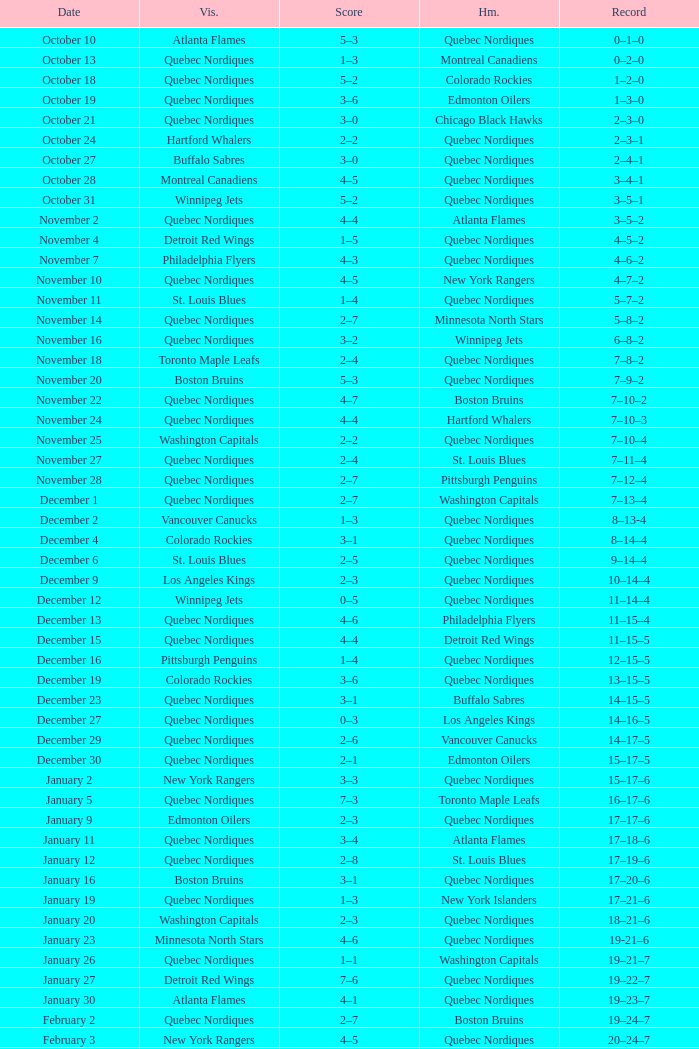Parse the table in full. {'header': ['Date', 'Vis.', 'Score', 'Hm.', 'Record'], 'rows': [['October 10', 'Atlanta Flames', '5–3', 'Quebec Nordiques', '0–1–0'], ['October 13', 'Quebec Nordiques', '1–3', 'Montreal Canadiens', '0–2–0'], ['October 18', 'Quebec Nordiques', '5–2', 'Colorado Rockies', '1–2–0'], ['October 19', 'Quebec Nordiques', '3–6', 'Edmonton Oilers', '1–3–0'], ['October 21', 'Quebec Nordiques', '3–0', 'Chicago Black Hawks', '2–3–0'], ['October 24', 'Hartford Whalers', '2–2', 'Quebec Nordiques', '2–3–1'], ['October 27', 'Buffalo Sabres', '3–0', 'Quebec Nordiques', '2–4–1'], ['October 28', 'Montreal Canadiens', '4–5', 'Quebec Nordiques', '3–4–1'], ['October 31', 'Winnipeg Jets', '5–2', 'Quebec Nordiques', '3–5–1'], ['November 2', 'Quebec Nordiques', '4–4', 'Atlanta Flames', '3–5–2'], ['November 4', 'Detroit Red Wings', '1–5', 'Quebec Nordiques', '4–5–2'], ['November 7', 'Philadelphia Flyers', '4–3', 'Quebec Nordiques', '4–6–2'], ['November 10', 'Quebec Nordiques', '4–5', 'New York Rangers', '4–7–2'], ['November 11', 'St. Louis Blues', '1–4', 'Quebec Nordiques', '5–7–2'], ['November 14', 'Quebec Nordiques', '2–7', 'Minnesota North Stars', '5–8–2'], ['November 16', 'Quebec Nordiques', '3–2', 'Winnipeg Jets', '6–8–2'], ['November 18', 'Toronto Maple Leafs', '2–4', 'Quebec Nordiques', '7–8–2'], ['November 20', 'Boston Bruins', '5–3', 'Quebec Nordiques', '7–9–2'], ['November 22', 'Quebec Nordiques', '4–7', 'Boston Bruins', '7–10–2'], ['November 24', 'Quebec Nordiques', '4–4', 'Hartford Whalers', '7–10–3'], ['November 25', 'Washington Capitals', '2–2', 'Quebec Nordiques', '7–10–4'], ['November 27', 'Quebec Nordiques', '2–4', 'St. Louis Blues', '7–11–4'], ['November 28', 'Quebec Nordiques', '2–7', 'Pittsburgh Penguins', '7–12–4'], ['December 1', 'Quebec Nordiques', '2–7', 'Washington Capitals', '7–13–4'], ['December 2', 'Vancouver Canucks', '1–3', 'Quebec Nordiques', '8–13-4'], ['December 4', 'Colorado Rockies', '3–1', 'Quebec Nordiques', '8–14–4'], ['December 6', 'St. Louis Blues', '2–5', 'Quebec Nordiques', '9–14–4'], ['December 9', 'Los Angeles Kings', '2–3', 'Quebec Nordiques', '10–14–4'], ['December 12', 'Winnipeg Jets', '0–5', 'Quebec Nordiques', '11–14–4'], ['December 13', 'Quebec Nordiques', '4–6', 'Philadelphia Flyers', '11–15–4'], ['December 15', 'Quebec Nordiques', '4–4', 'Detroit Red Wings', '11–15–5'], ['December 16', 'Pittsburgh Penguins', '1–4', 'Quebec Nordiques', '12–15–5'], ['December 19', 'Colorado Rockies', '3–6', 'Quebec Nordiques', '13–15–5'], ['December 23', 'Quebec Nordiques', '3–1', 'Buffalo Sabres', '14–15–5'], ['December 27', 'Quebec Nordiques', '0–3', 'Los Angeles Kings', '14–16–5'], ['December 29', 'Quebec Nordiques', '2–6', 'Vancouver Canucks', '14–17–5'], ['December 30', 'Quebec Nordiques', '2–1', 'Edmonton Oilers', '15–17–5'], ['January 2', 'New York Rangers', '3–3', 'Quebec Nordiques', '15–17–6'], ['January 5', 'Quebec Nordiques', '7–3', 'Toronto Maple Leafs', '16–17–6'], ['January 9', 'Edmonton Oilers', '2–3', 'Quebec Nordiques', '17–17–6'], ['January 11', 'Quebec Nordiques', '3–4', 'Atlanta Flames', '17–18–6'], ['January 12', 'Quebec Nordiques', '2–8', 'St. Louis Blues', '17–19–6'], ['January 16', 'Boston Bruins', '3–1', 'Quebec Nordiques', '17–20–6'], ['January 19', 'Quebec Nordiques', '1–3', 'New York Islanders', '17–21–6'], ['January 20', 'Washington Capitals', '2–3', 'Quebec Nordiques', '18–21–6'], ['January 23', 'Minnesota North Stars', '4–6', 'Quebec Nordiques', '19-21–6'], ['January 26', 'Quebec Nordiques', '1–1', 'Washington Capitals', '19–21–7'], ['January 27', 'Detroit Red Wings', '7–6', 'Quebec Nordiques', '19–22–7'], ['January 30', 'Atlanta Flames', '4–1', 'Quebec Nordiques', '19–23–7'], ['February 2', 'Quebec Nordiques', '2–7', 'Boston Bruins', '19–24–7'], ['February 3', 'New York Rangers', '4–5', 'Quebec Nordiques', '20–24–7'], ['February 6', 'Chicago Black Hawks', '3–3', 'Quebec Nordiques', '20–24–8'], ['February 9', 'Quebec Nordiques', '0–5', 'New York Islanders', '20–25–8'], ['February 10', 'Quebec Nordiques', '1–3', 'New York Rangers', '20–26–8'], ['February 14', 'Quebec Nordiques', '1–5', 'Montreal Canadiens', '20–27–8'], ['February 17', 'Quebec Nordiques', '5–6', 'Winnipeg Jets', '20–28–8'], ['February 18', 'Quebec Nordiques', '2–6', 'Minnesota North Stars', '20–29–8'], ['February 19', 'Buffalo Sabres', '3–1', 'Quebec Nordiques', '20–30–8'], ['February 23', 'Quebec Nordiques', '1–2', 'Pittsburgh Penguins', '20–31–8'], ['February 24', 'Pittsburgh Penguins', '0–2', 'Quebec Nordiques', '21–31–8'], ['February 26', 'Hartford Whalers', '5–9', 'Quebec Nordiques', '22–31–8'], ['February 27', 'New York Islanders', '5–3', 'Quebec Nordiques', '22–32–8'], ['March 2', 'Los Angeles Kings', '4–3', 'Quebec Nordiques', '22–33–8'], ['March 5', 'Minnesota North Stars', '3-3', 'Quebec Nordiques', '22–33–9'], ['March 8', 'Quebec Nordiques', '2–3', 'Toronto Maple Leafs', '22–34–9'], ['March 9', 'Toronto Maple Leafs', '4–5', 'Quebec Nordiques', '23–34-9'], ['March 12', 'Edmonton Oilers', '6–3', 'Quebec Nordiques', '23–35–9'], ['March 16', 'Vancouver Canucks', '3–2', 'Quebec Nordiques', '23–36–9'], ['March 19', 'Quebec Nordiques', '2–5', 'Chicago Black Hawks', '23–37–9'], ['March 20', 'Quebec Nordiques', '6–2', 'Colorado Rockies', '24–37–9'], ['March 22', 'Quebec Nordiques', '1-4', 'Los Angeles Kings', '24–38-9'], ['March 23', 'Quebec Nordiques', '6–2', 'Vancouver Canucks', '25–38–9'], ['March 26', 'Chicago Black Hawks', '7–2', 'Quebec Nordiques', '25–39–9'], ['March 27', 'Quebec Nordiques', '2–5', 'Philadelphia Flyers', '25–40–9'], ['March 29', 'Quebec Nordiques', '7–9', 'Detroit Red Wings', '25–41–9'], ['March 30', 'New York Islanders', '9–6', 'Quebec Nordiques', '25–42–9'], ['April 1', 'Philadelphia Flyers', '3–3', 'Quebec Nordiques', '25–42–10'], ['April 3', 'Quebec Nordiques', '3–8', 'Buffalo Sabres', '25–43–10'], ['April 4', 'Quebec Nordiques', '2–9', 'Hartford Whalers', '25–44–10'], ['April 6', 'Montreal Canadiens', '4–4', 'Quebec Nordiques', '25–44–11']]} Which Date has a Score of 2–7, and a Record of 5–8–2? November 14. 